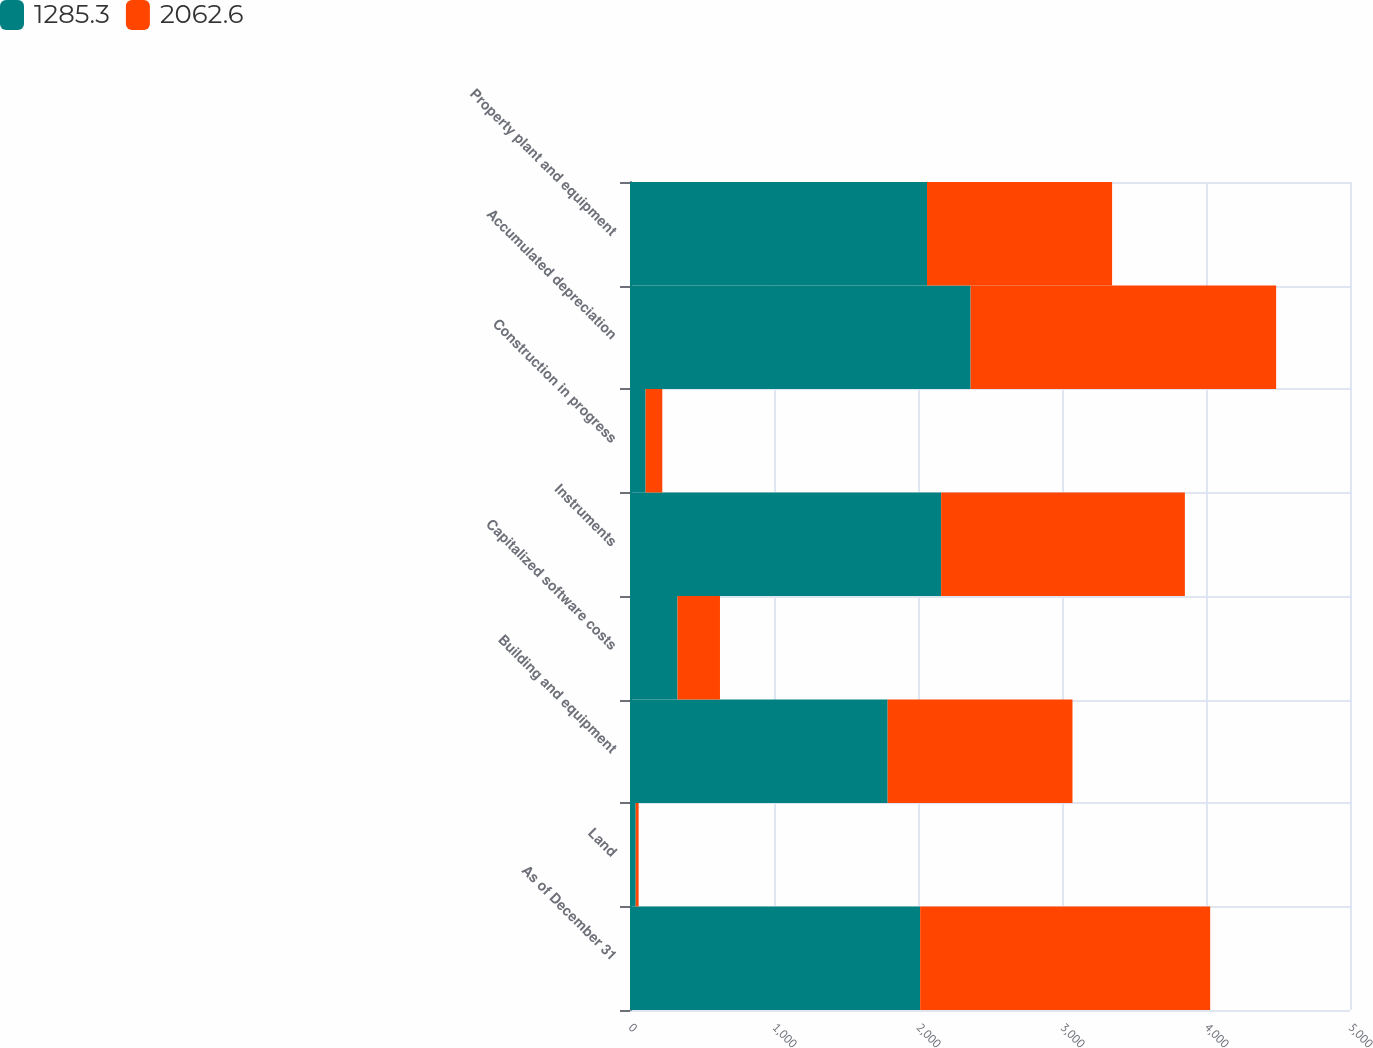<chart> <loc_0><loc_0><loc_500><loc_500><stacked_bar_chart><ecel><fcel>As of December 31<fcel>Land<fcel>Building and equipment<fcel>Capitalized software costs<fcel>Instruments<fcel>Construction in progress<fcel>Accumulated depreciation<fcel>Property plant and equipment<nl><fcel>1285.3<fcel>2015<fcel>39.6<fcel>1789.3<fcel>330.1<fcel>2160.5<fcel>108.4<fcel>2365.3<fcel>2062.6<nl><fcel>2062.6<fcel>2014<fcel>20.4<fcel>1283.4<fcel>294.7<fcel>1692.8<fcel>115.8<fcel>2121.8<fcel>1285.3<nl></chart> 